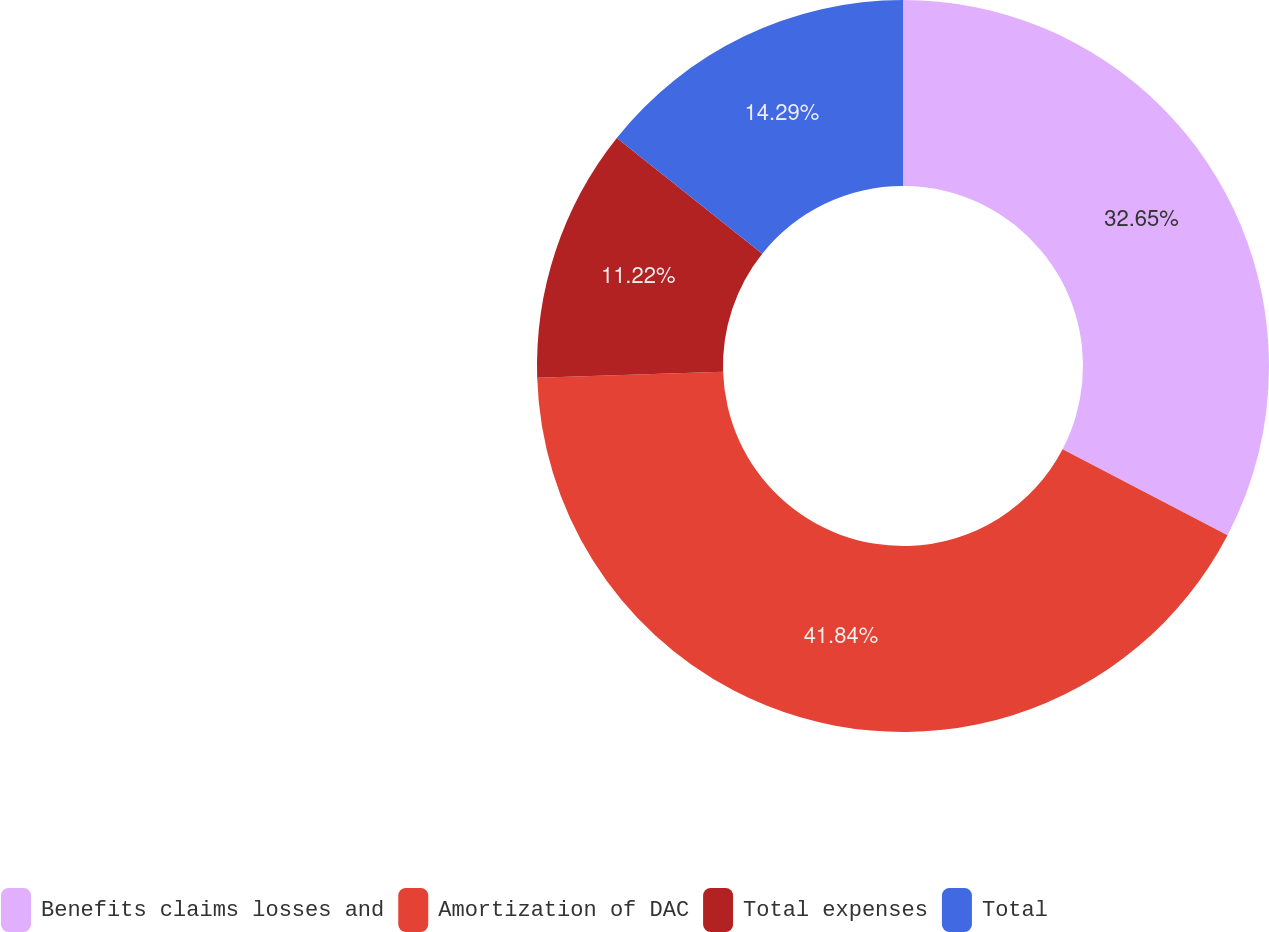Convert chart. <chart><loc_0><loc_0><loc_500><loc_500><pie_chart><fcel>Benefits claims losses and<fcel>Amortization of DAC<fcel>Total expenses<fcel>Total<nl><fcel>32.65%<fcel>41.84%<fcel>11.22%<fcel>14.29%<nl></chart> 